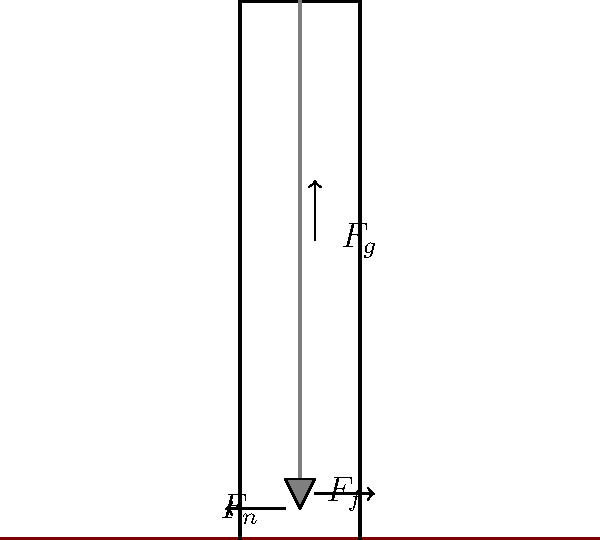In the operation of a traditional oil drilling rig, what key physics principle allows for efficient drilling through layers of rock and soil? How does this principle relate to the forces acting on the drill bit? To understand the physics behind oil drilling, let's break it down step-by-step:

1. Gravitational Force ($F_g$):
   The weight of the drill string and bit creates a downward force due to gravity. This is essential for penetrating the ground.

2. Normal Force ($F_n$):
   The ground exerts an upward normal force on the drill bit, opposing the gravitational force.

3. Rotational Motion:
   The drill string is rotated, typically by a motor at the surface. This rotation is crucial for the drilling process.

4. Friction Force ($F_f$):
   As the drill bit rotates against the rock, it experiences a frictional force. This friction is actually beneficial to the drilling process.

5. Work and Energy Conversion:
   The rotational energy of the drill string is converted into work done against friction. This work manifests as breaking chemical bonds in the rock and increasing its temperature.

6. Pressure:
   The weight of the drill string, combined with the rotational force, creates high pressure at the drill bit-rock interface. This pressure helps in breaking down the rock structure.

7. Heat Generation:
   The friction between the drill bit and rock generates significant heat, which helps to weaken the rock structure further.

8. Fluid Dynamics:
   Drilling fluid (mud) is pumped down the drill string and exits through nozzles in the drill bit. This fluid serves multiple purposes:
   a) It cools the drill bit
   b) It carries rock cuttings back to the surface
   c) It maintains pressure in the wellbore

The key principle at work here is the conversion of rotational kinetic energy into work done against friction, which breaks down the rock. The efficiency of this process is enhanced by the pressure created by the weight of the drill string and the auxiliary effects of heat generation and fluid dynamics.
Answer: Energy conversion from rotational kinetic energy to work against friction, breaking rock bonds. 